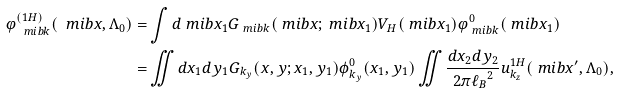Convert formula to latex. <formula><loc_0><loc_0><loc_500><loc_500>\varphi _ { \ m i b { k } } ^ { ( 1 H ) } ( \ m i b { x } , \Lambda _ { 0 } ) = & \int d \ m i b { x } _ { 1 } G _ { \ m i b { k } } ( \ m i b { x } ; \ m i b { x } _ { 1 } ) V _ { H } ( \ m i b { x } _ { 1 } ) \varphi _ { \ m i b { k } } ^ { 0 } ( \ m i b { x } _ { 1 } ) \\ = & \iint d x _ { 1 } d y _ { 1 } G _ { k _ { y } } ( x , y ; x _ { 1 } , y _ { 1 } ) \phi _ { k _ { y } } ^ { 0 } ( x _ { 1 } , y _ { 1 } ) \iint \frac { d x _ { 2 } d y _ { 2 } } { 2 \pi { \ell _ { B } } ^ { 2 } } u _ { k _ { z } } ^ { 1 H } ( \ m i b { x } ^ { \prime } , \Lambda _ { 0 } ) ,</formula> 